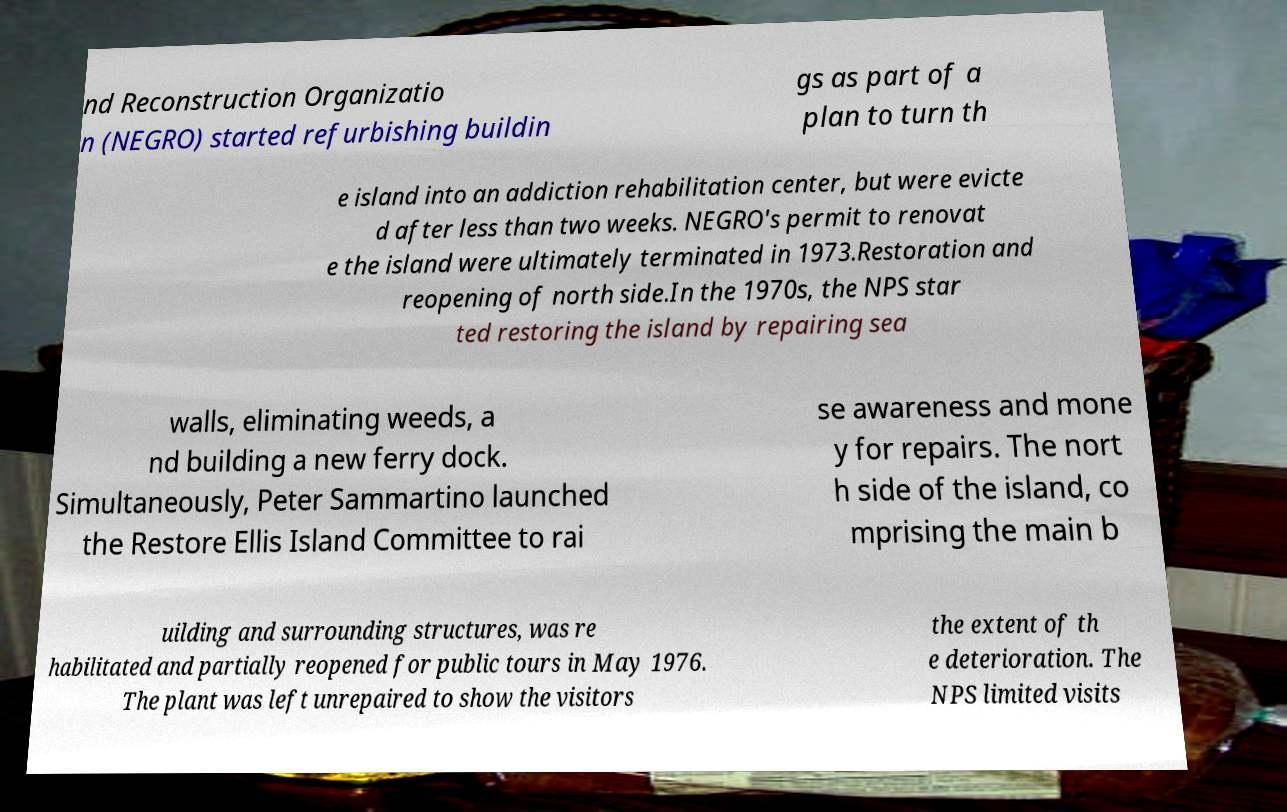Could you assist in decoding the text presented in this image and type it out clearly? nd Reconstruction Organizatio n (NEGRO) started refurbishing buildin gs as part of a plan to turn th e island into an addiction rehabilitation center, but were evicte d after less than two weeks. NEGRO's permit to renovat e the island were ultimately terminated in 1973.Restoration and reopening of north side.In the 1970s, the NPS star ted restoring the island by repairing sea walls, eliminating weeds, a nd building a new ferry dock. Simultaneously, Peter Sammartino launched the Restore Ellis Island Committee to rai se awareness and mone y for repairs. The nort h side of the island, co mprising the main b uilding and surrounding structures, was re habilitated and partially reopened for public tours in May 1976. The plant was left unrepaired to show the visitors the extent of th e deterioration. The NPS limited visits 